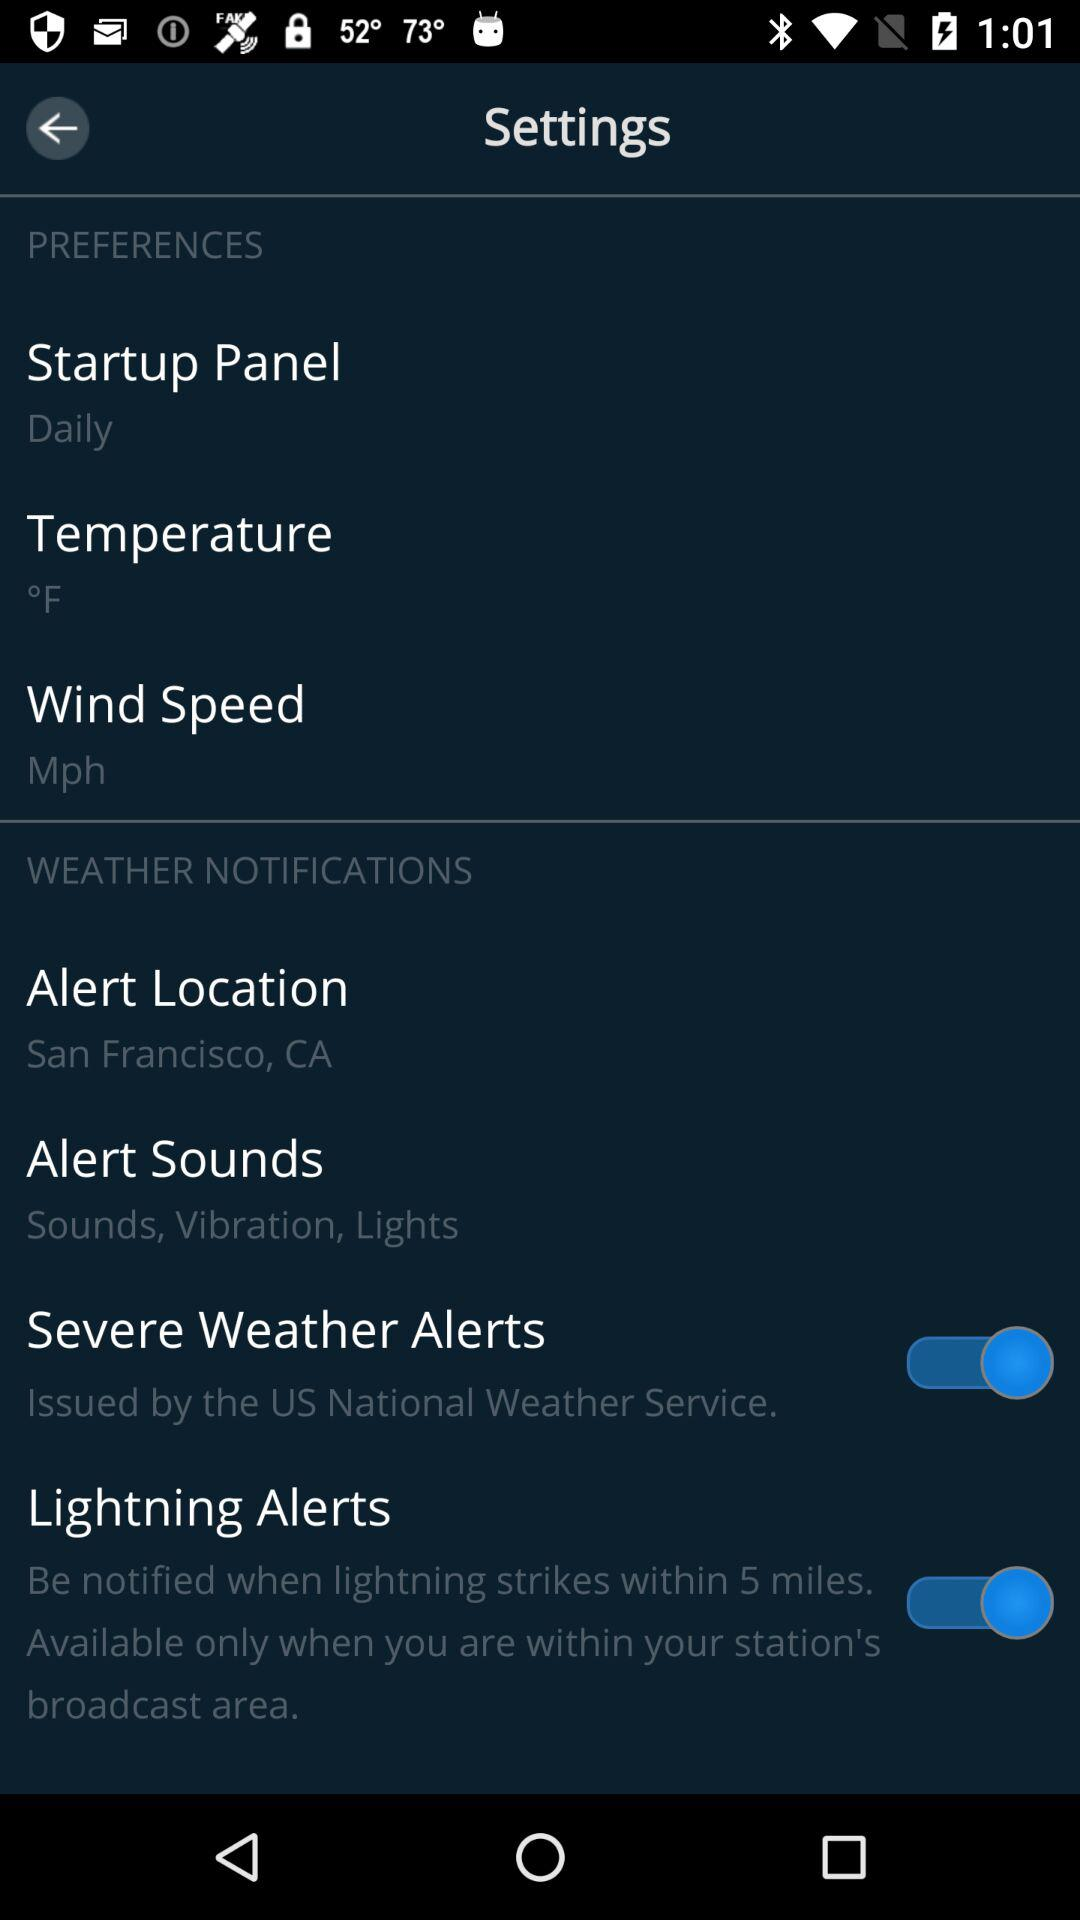What are the enabled settings? The enabled settings are "Severe Weather Alerts" and "Lightning Alerts". 